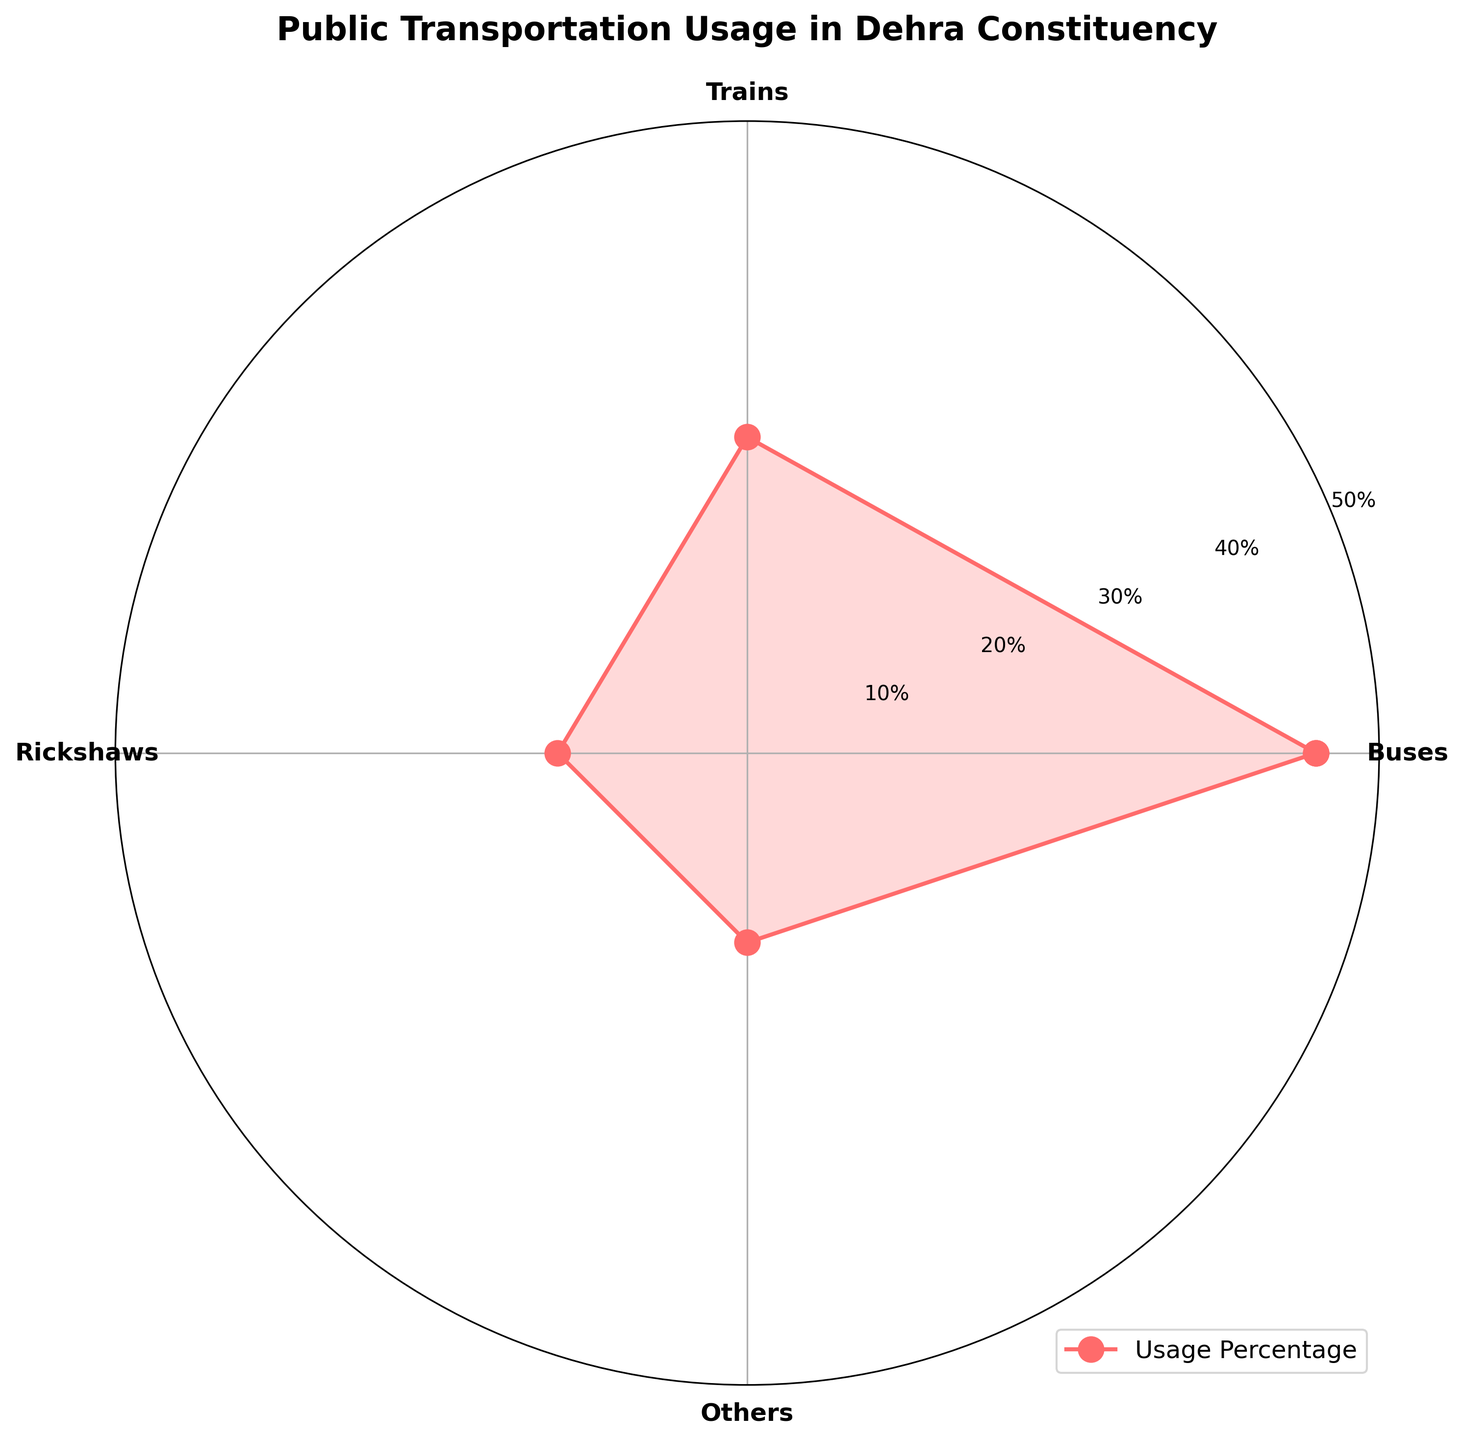What is the title of the plot? The title is located at the top of the plot and it provides an overview of what the plot is depicting.
Answer: Public Transportation Usage in Dehra Constituency What are the four modes of transportation shown in the plot? The modes of transportation are labeled around the outer edge of the polar chart.
Answer: Buses, Trains, Rickshaws, Others Which transportation mode has the highest usage percentage? By observing the data points and the filled area on the polar chart, you can see the highest peak corresponds to Buses.
Answer: Buses Which two transportation modes have equal usage percentages? By looking at the data points and their corresponding angles, you can see that Rickshaws and Others both have the same percentage values.
Answer: Rickshaws and Others What is the range of the radial ticks shown in the plot? The radial ticks are the concentric circles with percentage labels, which range from the innermost to the outermost tick.
Answer: 10% to 50% What is the total percentage of public transportation usage for Trains and Rickshaws combined? Adding up the percentages from the plot for Trains and Rickshaws (25% + 15%).
Answer: 40% Which mode of transportation has exactly half the usage percentage of Buses? Buses have a usage percentage of 45%, looking for a transport mode that has half of this value which is 22.5%. Since Trains' 25% is closest but not exact, no mode fits exactly.
Answer: None How much more is the usage percentage of Buses compared to Trains? Subtracting the percentage of Trains from the percentage of Buses (45% - 25%).
Answer: 20% What percentage less do Rickshaws and Others each have compared to Buses? Subtract each of their percentages from Buses' percentage: (45% - 15%) for Rickshaws and (45% - 15%) for Others.
Answer: 30% What is the average usage percentage across all modes of transportation? Sum all the percentages and divide by the number of modes [(45 + 25 + 15 + 15) / 4].
Answer: 25% 